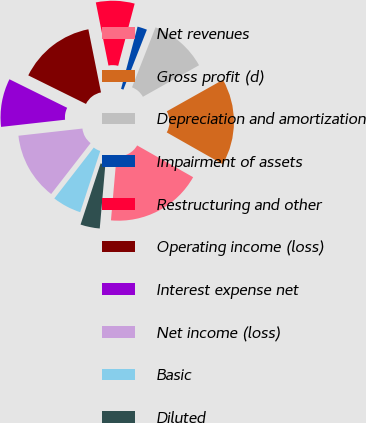Convert chart to OTSL. <chart><loc_0><loc_0><loc_500><loc_500><pie_chart><fcel>Net revenues<fcel>Gross profit (d)<fcel>Depreciation and amortization<fcel>Impairment of assets<fcel>Restructuring and other<fcel>Operating income (loss)<fcel>Interest expense net<fcel>Net income (loss)<fcel>Basic<fcel>Diluted<nl><fcel>18.18%<fcel>16.36%<fcel>10.91%<fcel>1.82%<fcel>7.27%<fcel>14.54%<fcel>9.09%<fcel>12.73%<fcel>5.46%<fcel>3.64%<nl></chart> 